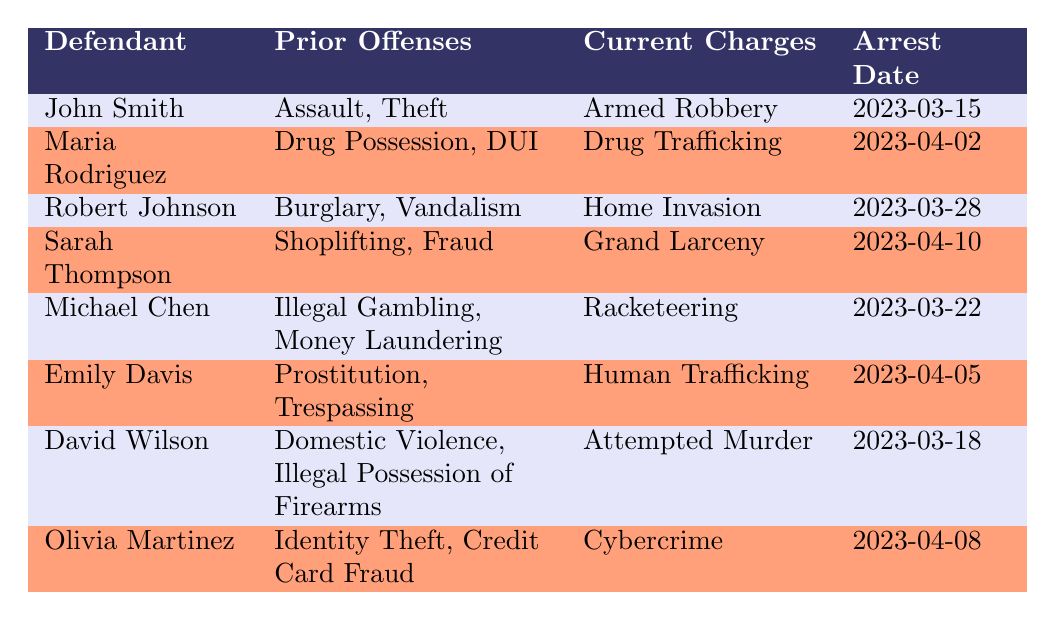What are the current charges against John Smith? By looking at the row corresponding to John Smith, the current charges listed are "Armed Robbery."
Answer: Armed Robbery How many defendants have prior offenses related to theft? Reviewing the table, John Smith (Assault, Theft) and Sarah Thompson (Shoplifting, Fraud) both have prior offenses related to theft, totaling 2 defendants.
Answer: 2 Is Emily Davis charged with a violent crime? Human Trafficking is not typically classified as a violent crime. Therefore, the answer is no.
Answer: No Which defendant has the earliest arrest date? The arrest dates listed are: John Smith (2023-03-15), Maria Rodriguez (2023-04-02), Robert Johnson (2023-03-28), Sarah Thompson (2023-04-10), Michael Chen (2023-03-22), Emily Davis (2023-04-05), David Wilson (2023-03-18), Olivia Martinez (2023-04-08). The earliest date is 2023-03-15, corresponding to John Smith.
Answer: John Smith How many total prior offense types are listed for Robert Johnson? Robert Johnson has two prior offenses listed: Burglary and Vandalism. Thus, the total number of offense types for him is 2.
Answer: 2 Are there any defendants with prior offenses of drug-related crimes? Yes, there are two defendants: Maria Rodriguez (Drug Possession, DUI) and Emily Davis’s charges relate to drug trafficking due to their current charge.
Answer: Yes Who has the most serious current charge based on the table? Based on the seriousness of the charges listed, "Attempted Murder" for David Wilson is typically considered the most serious offense compared to the others.
Answer: David Wilson Which two defendants have prior offenses that include violence? David Wilson has Domestic Violence and Illegal Possession of Firearms as prior offenses. John Smith's prior offense of Assault also includes violence. Therefore, the two defendants are John Smith and David Wilson.
Answer: John Smith and David Wilson What is the total number of defendants in the table? There are eight defendants listed in the table, which can be counted directly in the rows.
Answer: 8 